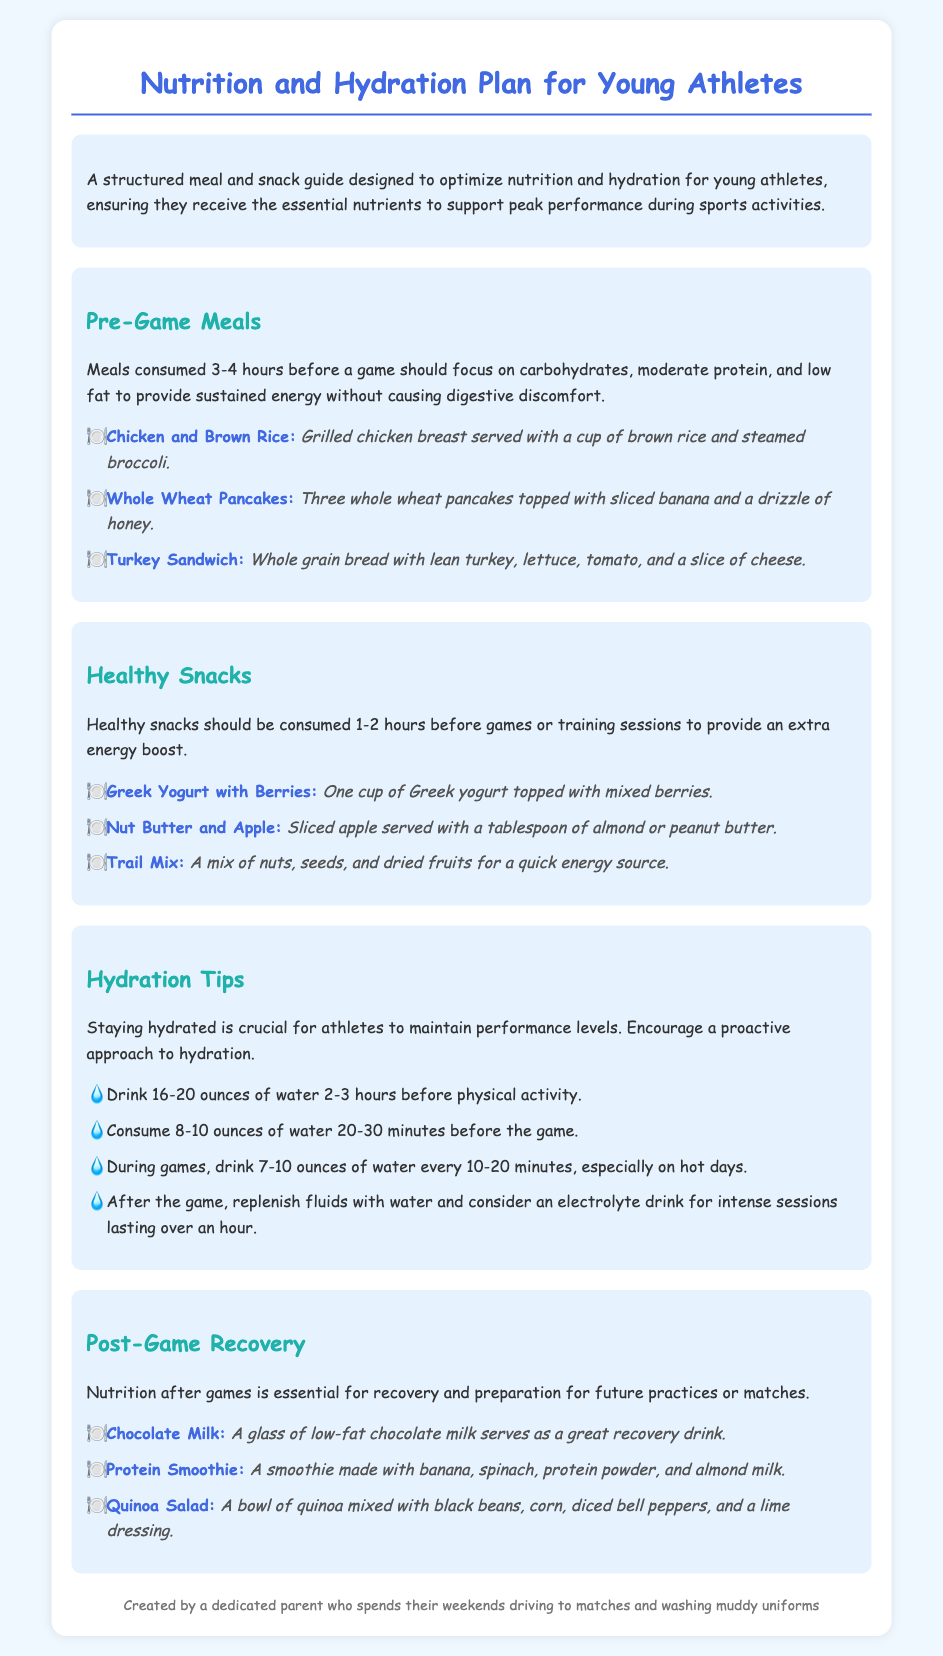What is the focus of pre-game meals? Pre-game meals should focus on carbohydrates, moderate protein, and low fat to provide sustained energy without causing digestive discomfort.
Answer: Carbohydrates, moderate protein, low fat How many ounces of water should be consumed 2-3 hours before activity? The document states that athletes should drink 16-20 ounces of water 2-3 hours before physical activity.
Answer: 16-20 ounces What is a recommended post-game recovery drink? A glass of low-fat chocolate milk is mentioned as a great recovery drink after a game.
Answer: Chocolate Milk List one healthy snack option mentioned in the document. The document provides several healthy snack options; one example is Greek Yogurt with Berries.
Answer: Greek Yogurt with Berries What is said about hydration after the game? The document emphasizes the importance of replenishing fluids with water and suggests considering an electrolyte drink for intense sessions over an hour.
Answer: Replenish fluids with water and electrolyte drink What is the main purpose of the Nutrition and Hydration Plan? The primary aim of the plan is to optimize nutrition and hydration to support peak performance in young athletes during sports activities.
Answer: Optimize nutrition and hydration How long before a game should healthy snacks be consumed? Healthy snacks should be consumed 1-2 hours before games or training sessions.
Answer: 1-2 hours What kind of bread is mentioned in the turkey sandwich option? The turkey sandwich is made with whole grain bread.
Answer: Whole grain bread 